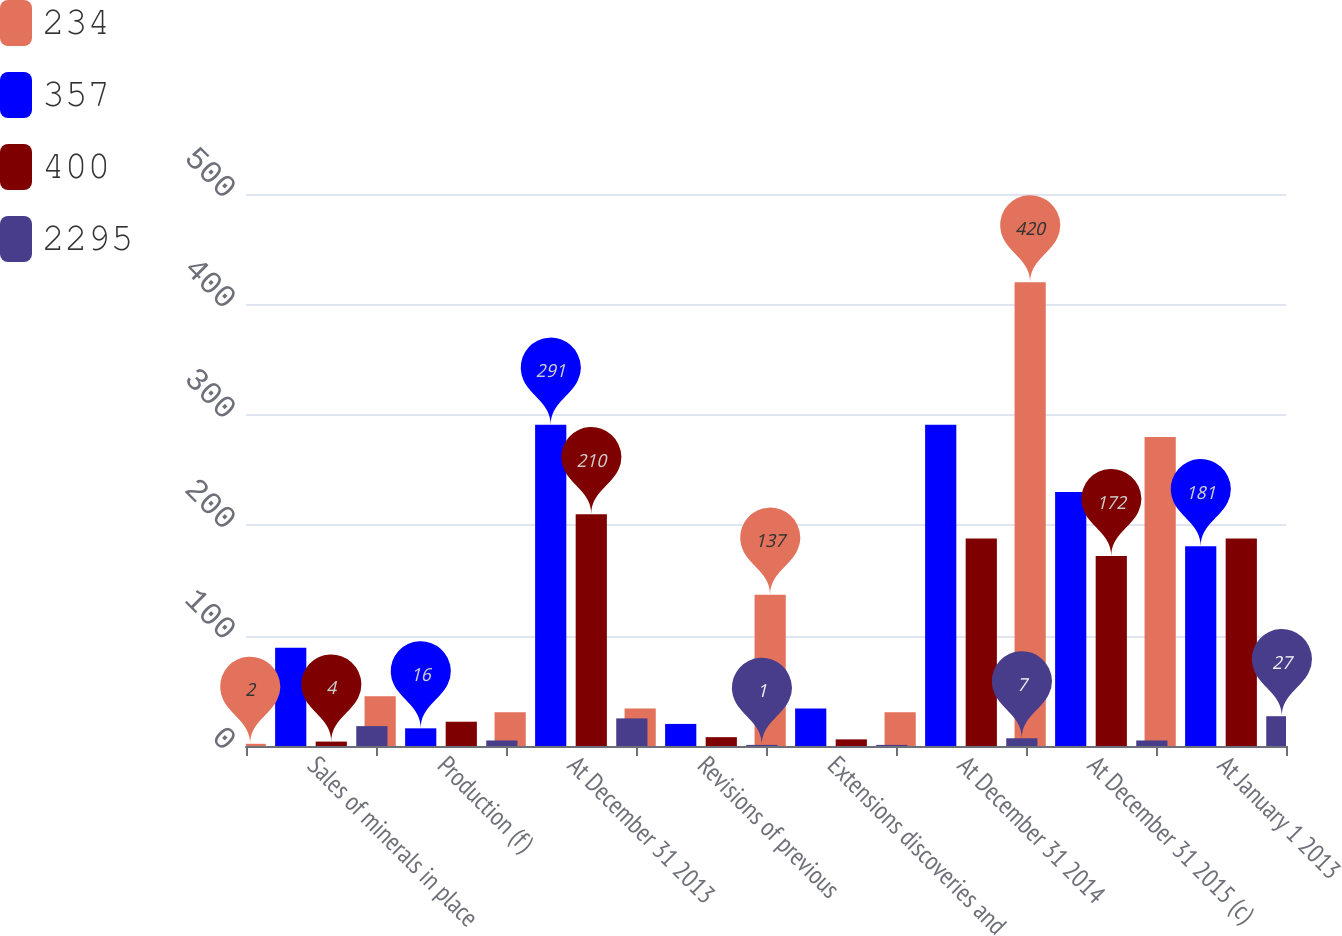Convert chart. <chart><loc_0><loc_0><loc_500><loc_500><stacked_bar_chart><ecel><fcel>Sales of minerals in place<fcel>Production (f)<fcel>At December 31 2013<fcel>Revisions of previous<fcel>Extensions discoveries and<fcel>At December 31 2014<fcel>At December 31 2015 (c)<fcel>At January 1 2013<nl><fcel>234<fcel>2<fcel>45<fcel>30.5<fcel>34<fcel>137<fcel>30.5<fcel>420<fcel>280<nl><fcel>357<fcel>89<fcel>16<fcel>291<fcel>20<fcel>34<fcel>291<fcel>230<fcel>181<nl><fcel>400<fcel>4<fcel>22<fcel>210<fcel>8<fcel>6<fcel>188<fcel>172<fcel>188<nl><fcel>2295<fcel>18<fcel>5<fcel>25<fcel>1<fcel>1<fcel>7<fcel>5<fcel>27<nl></chart> 